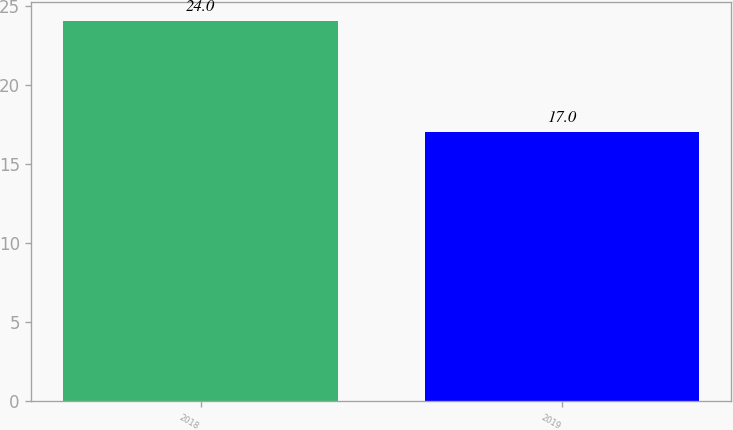Convert chart. <chart><loc_0><loc_0><loc_500><loc_500><bar_chart><fcel>2018<fcel>2019<nl><fcel>24<fcel>17<nl></chart> 